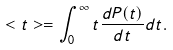Convert formula to latex. <formula><loc_0><loc_0><loc_500><loc_500>< t > = \int _ { 0 } ^ { \infty } t \frac { d P ( t ) } { d t } d t .</formula> 